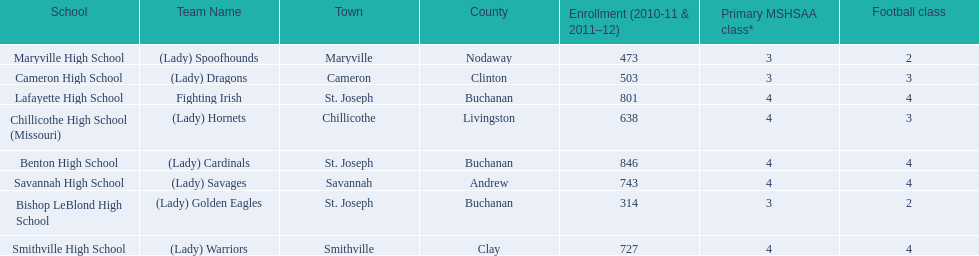What is the lowest number of students enrolled at a school as listed here? 314. What school has 314 students enrolled? Bishop LeBlond High School. 